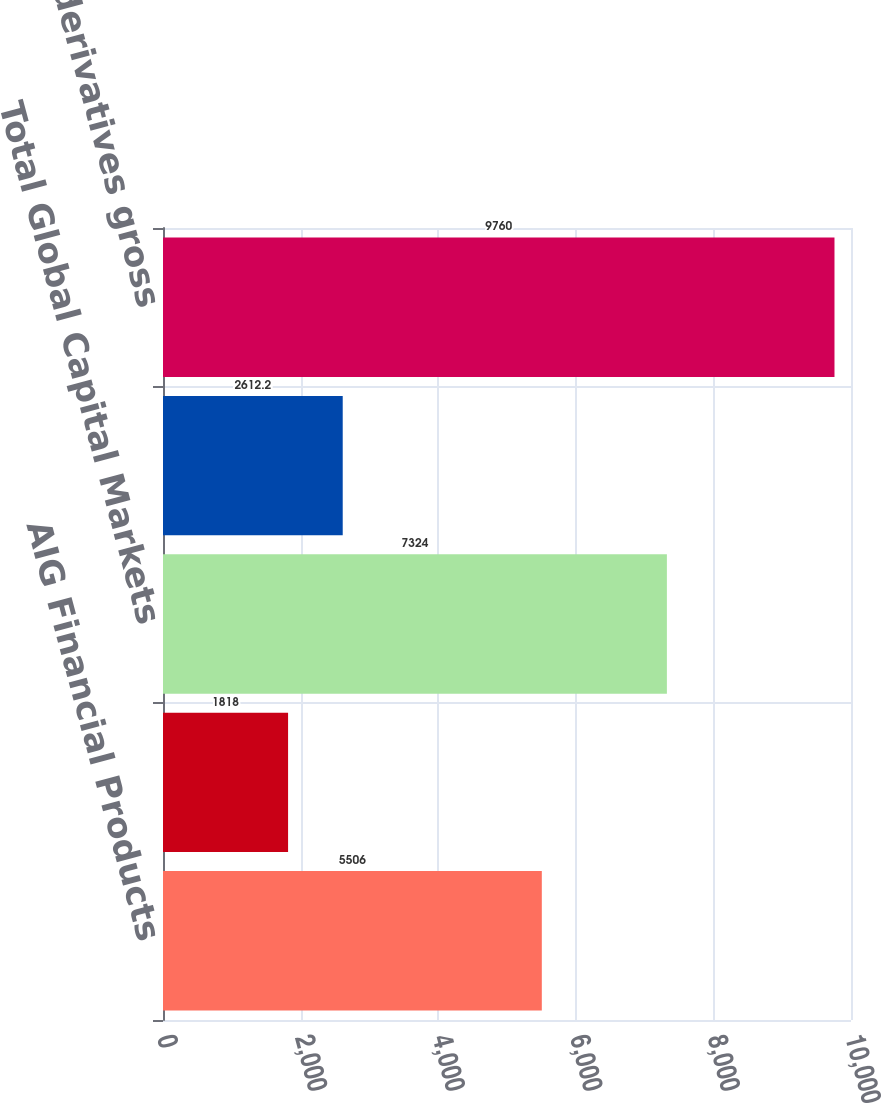Convert chart to OTSL. <chart><loc_0><loc_0><loc_500><loc_500><bar_chart><fcel>AIG Financial Products<fcel>AIG Markets<fcel>Total Global Capital Markets<fcel>Non-Global Capital Markets<fcel>Total derivatives gross<nl><fcel>5506<fcel>1818<fcel>7324<fcel>2612.2<fcel>9760<nl></chart> 